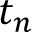<formula> <loc_0><loc_0><loc_500><loc_500>t _ { n }</formula> 